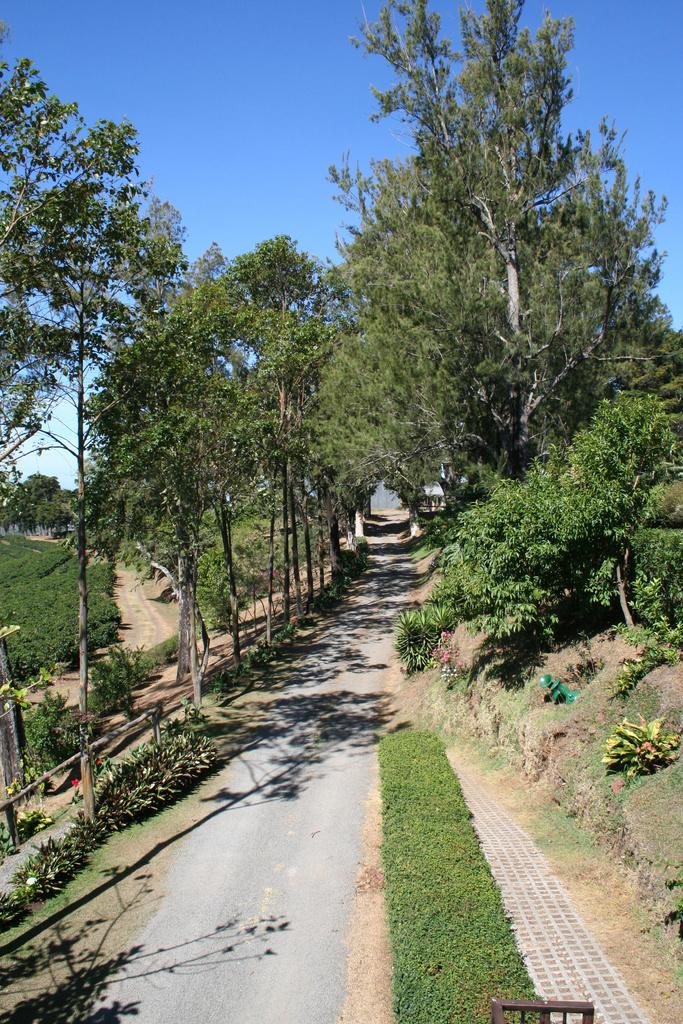What type of vegetation can be seen in the image? There are trees in the image. What is covering the ground in the image? The ground is covered with grass. What is the condition of the sky in the image? The sky is clear in the image. What type of watch can be seen on the tree in the image? There is no watch present in the image; it features trees, grass-covered ground, and a clear sky. Is there a house visible in the image? There is no house mentioned or visible in the image. 